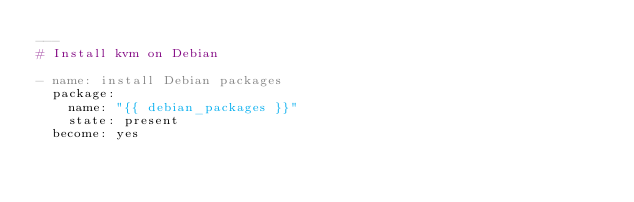Convert code to text. <code><loc_0><loc_0><loc_500><loc_500><_YAML_>---
# Install kvm on Debian

- name: install Debian packages
  package:
    name: "{{ debian_packages }}"
    state: present
  become: yes
</code> 